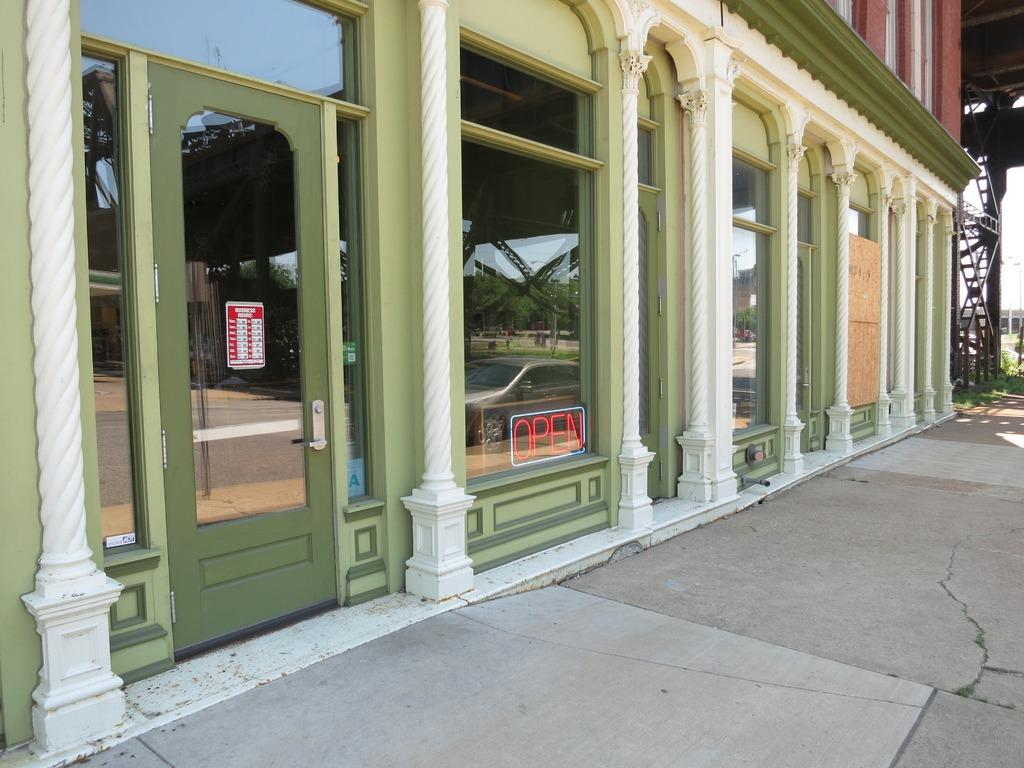What type of structure is present in the image? There is a building in the image. What feature of the building is mentioned in the facts? The building has glass doors. What can be seen reflected in the glass doors? The glass doors reflect trees, a car, and another building. What else is visible in the image besides the building and glass doors? There are poles visible in the image. What type of dress is hanging on the pole in the image? There is no dress present in the image; only a building, glass doors, their reflection, and poles are mentioned in the facts. 